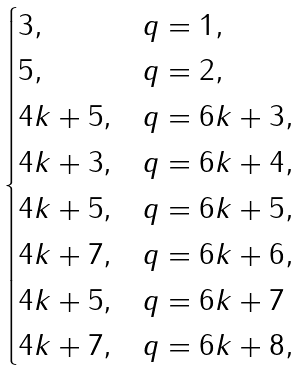<formula> <loc_0><loc_0><loc_500><loc_500>\begin{cases} 3 , & q = 1 , \\ 5 , & q = 2 , \\ { 4 k + 5 } , & q = 6 k + 3 , \\ { 4 k + 3 } , & q = 6 k + 4 , \\ { 4 k + 5 } , & q = 6 k + 5 , \\ { 4 k + 7 } , & q = 6 k + 6 , \\ { 4 k + 5 } , & q = 6 k + 7 \\ { 4 k + 7 } , & q = 6 k + 8 , \end{cases}</formula> 